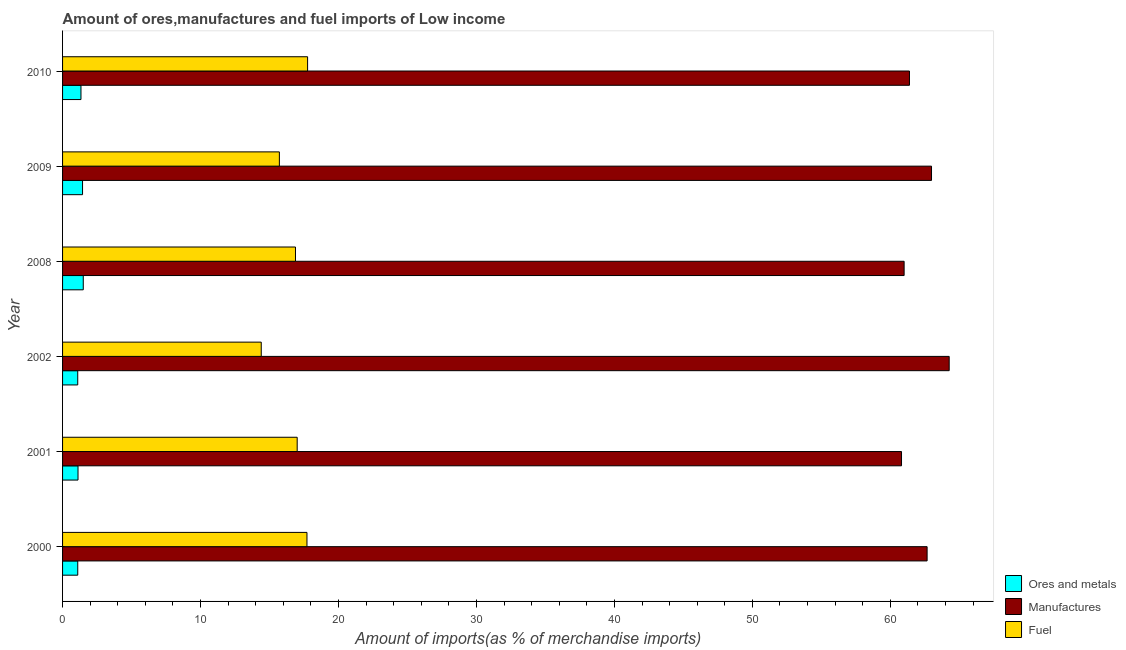How many different coloured bars are there?
Your answer should be compact. 3. How many bars are there on the 5th tick from the top?
Offer a very short reply. 3. How many bars are there on the 4th tick from the bottom?
Offer a very short reply. 3. What is the label of the 5th group of bars from the top?
Give a very brief answer. 2001. In how many cases, is the number of bars for a given year not equal to the number of legend labels?
Offer a very short reply. 0. What is the percentage of fuel imports in 2010?
Your response must be concise. 17.76. Across all years, what is the maximum percentage of manufactures imports?
Offer a very short reply. 64.27. Across all years, what is the minimum percentage of ores and metals imports?
Provide a short and direct response. 1.1. In which year was the percentage of ores and metals imports minimum?
Keep it short and to the point. 2002. What is the total percentage of manufactures imports in the graph?
Offer a terse response. 373.12. What is the difference between the percentage of fuel imports in 2000 and that in 2010?
Your answer should be compact. -0.04. What is the difference between the percentage of ores and metals imports in 2009 and the percentage of manufactures imports in 2000?
Offer a very short reply. -61.22. What is the average percentage of ores and metals imports per year?
Offer a terse response. 1.27. In the year 2002, what is the difference between the percentage of fuel imports and percentage of ores and metals imports?
Give a very brief answer. 13.3. Is the percentage of fuel imports in 2001 less than that in 2009?
Provide a short and direct response. No. Is the difference between the percentage of manufactures imports in 2000 and 2010 greater than the difference between the percentage of ores and metals imports in 2000 and 2010?
Offer a very short reply. Yes. What is the difference between the highest and the second highest percentage of manufactures imports?
Your answer should be very brief. 1.28. What is the difference between the highest and the lowest percentage of fuel imports?
Offer a terse response. 3.36. What does the 2nd bar from the top in 2001 represents?
Offer a very short reply. Manufactures. What does the 1st bar from the bottom in 2001 represents?
Your answer should be compact. Ores and metals. Is it the case that in every year, the sum of the percentage of ores and metals imports and percentage of manufactures imports is greater than the percentage of fuel imports?
Ensure brevity in your answer.  Yes. How many bars are there?
Offer a very short reply. 18. Are all the bars in the graph horizontal?
Make the answer very short. Yes. Are the values on the major ticks of X-axis written in scientific E-notation?
Provide a succinct answer. No. Does the graph contain grids?
Give a very brief answer. No. Where does the legend appear in the graph?
Ensure brevity in your answer.  Bottom right. What is the title of the graph?
Your response must be concise. Amount of ores,manufactures and fuel imports of Low income. What is the label or title of the X-axis?
Make the answer very short. Amount of imports(as % of merchandise imports). What is the label or title of the Y-axis?
Provide a short and direct response. Year. What is the Amount of imports(as % of merchandise imports) of Ores and metals in 2000?
Offer a terse response. 1.1. What is the Amount of imports(as % of merchandise imports) in Manufactures in 2000?
Ensure brevity in your answer.  62.67. What is the Amount of imports(as % of merchandise imports) in Fuel in 2000?
Your answer should be very brief. 17.72. What is the Amount of imports(as % of merchandise imports) in Ores and metals in 2001?
Provide a succinct answer. 1.12. What is the Amount of imports(as % of merchandise imports) in Manufactures in 2001?
Make the answer very short. 60.81. What is the Amount of imports(as % of merchandise imports) in Fuel in 2001?
Your answer should be very brief. 17.01. What is the Amount of imports(as % of merchandise imports) in Ores and metals in 2002?
Offer a very short reply. 1.1. What is the Amount of imports(as % of merchandise imports) in Manufactures in 2002?
Keep it short and to the point. 64.27. What is the Amount of imports(as % of merchandise imports) in Fuel in 2002?
Ensure brevity in your answer.  14.4. What is the Amount of imports(as % of merchandise imports) in Ores and metals in 2008?
Provide a succinct answer. 1.5. What is the Amount of imports(as % of merchandise imports) in Manufactures in 2008?
Give a very brief answer. 61. What is the Amount of imports(as % of merchandise imports) in Fuel in 2008?
Ensure brevity in your answer.  16.88. What is the Amount of imports(as % of merchandise imports) in Ores and metals in 2009?
Give a very brief answer. 1.45. What is the Amount of imports(as % of merchandise imports) of Manufactures in 2009?
Provide a short and direct response. 62.99. What is the Amount of imports(as % of merchandise imports) of Fuel in 2009?
Your response must be concise. 15.72. What is the Amount of imports(as % of merchandise imports) of Ores and metals in 2010?
Offer a terse response. 1.33. What is the Amount of imports(as % of merchandise imports) of Manufactures in 2010?
Make the answer very short. 61.39. What is the Amount of imports(as % of merchandise imports) of Fuel in 2010?
Offer a very short reply. 17.76. Across all years, what is the maximum Amount of imports(as % of merchandise imports) in Ores and metals?
Give a very brief answer. 1.5. Across all years, what is the maximum Amount of imports(as % of merchandise imports) of Manufactures?
Your answer should be very brief. 64.27. Across all years, what is the maximum Amount of imports(as % of merchandise imports) of Fuel?
Offer a terse response. 17.76. Across all years, what is the minimum Amount of imports(as % of merchandise imports) in Ores and metals?
Your response must be concise. 1.1. Across all years, what is the minimum Amount of imports(as % of merchandise imports) in Manufactures?
Your response must be concise. 60.81. Across all years, what is the minimum Amount of imports(as % of merchandise imports) of Fuel?
Give a very brief answer. 14.4. What is the total Amount of imports(as % of merchandise imports) of Ores and metals in the graph?
Offer a very short reply. 7.6. What is the total Amount of imports(as % of merchandise imports) in Manufactures in the graph?
Your answer should be very brief. 373.12. What is the total Amount of imports(as % of merchandise imports) of Fuel in the graph?
Your answer should be compact. 99.48. What is the difference between the Amount of imports(as % of merchandise imports) in Ores and metals in 2000 and that in 2001?
Your response must be concise. -0.02. What is the difference between the Amount of imports(as % of merchandise imports) in Manufactures in 2000 and that in 2001?
Provide a succinct answer. 1.86. What is the difference between the Amount of imports(as % of merchandise imports) in Fuel in 2000 and that in 2001?
Keep it short and to the point. 0.71. What is the difference between the Amount of imports(as % of merchandise imports) in Ores and metals in 2000 and that in 2002?
Offer a very short reply. 0. What is the difference between the Amount of imports(as % of merchandise imports) in Manufactures in 2000 and that in 2002?
Give a very brief answer. -1.6. What is the difference between the Amount of imports(as % of merchandise imports) of Fuel in 2000 and that in 2002?
Offer a very short reply. 3.31. What is the difference between the Amount of imports(as % of merchandise imports) in Ores and metals in 2000 and that in 2008?
Ensure brevity in your answer.  -0.4. What is the difference between the Amount of imports(as % of merchandise imports) of Manufactures in 2000 and that in 2008?
Give a very brief answer. 1.67. What is the difference between the Amount of imports(as % of merchandise imports) in Ores and metals in 2000 and that in 2009?
Provide a short and direct response. -0.35. What is the difference between the Amount of imports(as % of merchandise imports) of Manufactures in 2000 and that in 2009?
Offer a very short reply. -0.32. What is the difference between the Amount of imports(as % of merchandise imports) in Fuel in 2000 and that in 2009?
Your response must be concise. 2. What is the difference between the Amount of imports(as % of merchandise imports) in Ores and metals in 2000 and that in 2010?
Provide a short and direct response. -0.23. What is the difference between the Amount of imports(as % of merchandise imports) in Manufactures in 2000 and that in 2010?
Make the answer very short. 1.28. What is the difference between the Amount of imports(as % of merchandise imports) in Fuel in 2000 and that in 2010?
Keep it short and to the point. -0.04. What is the difference between the Amount of imports(as % of merchandise imports) of Ores and metals in 2001 and that in 2002?
Give a very brief answer. 0.02. What is the difference between the Amount of imports(as % of merchandise imports) of Manufactures in 2001 and that in 2002?
Ensure brevity in your answer.  -3.46. What is the difference between the Amount of imports(as % of merchandise imports) in Fuel in 2001 and that in 2002?
Offer a terse response. 2.6. What is the difference between the Amount of imports(as % of merchandise imports) of Ores and metals in 2001 and that in 2008?
Your answer should be compact. -0.38. What is the difference between the Amount of imports(as % of merchandise imports) in Manufactures in 2001 and that in 2008?
Ensure brevity in your answer.  -0.19. What is the difference between the Amount of imports(as % of merchandise imports) in Fuel in 2001 and that in 2008?
Give a very brief answer. 0.12. What is the difference between the Amount of imports(as % of merchandise imports) in Ores and metals in 2001 and that in 2009?
Your response must be concise. -0.33. What is the difference between the Amount of imports(as % of merchandise imports) of Manufactures in 2001 and that in 2009?
Make the answer very short. -2.17. What is the difference between the Amount of imports(as % of merchandise imports) of Fuel in 2001 and that in 2009?
Give a very brief answer. 1.29. What is the difference between the Amount of imports(as % of merchandise imports) of Ores and metals in 2001 and that in 2010?
Offer a terse response. -0.21. What is the difference between the Amount of imports(as % of merchandise imports) of Manufactures in 2001 and that in 2010?
Provide a short and direct response. -0.58. What is the difference between the Amount of imports(as % of merchandise imports) in Fuel in 2001 and that in 2010?
Keep it short and to the point. -0.75. What is the difference between the Amount of imports(as % of merchandise imports) in Ores and metals in 2002 and that in 2008?
Your answer should be very brief. -0.4. What is the difference between the Amount of imports(as % of merchandise imports) of Manufactures in 2002 and that in 2008?
Provide a short and direct response. 3.27. What is the difference between the Amount of imports(as % of merchandise imports) of Fuel in 2002 and that in 2008?
Your answer should be very brief. -2.48. What is the difference between the Amount of imports(as % of merchandise imports) of Ores and metals in 2002 and that in 2009?
Offer a very short reply. -0.35. What is the difference between the Amount of imports(as % of merchandise imports) in Manufactures in 2002 and that in 2009?
Your response must be concise. 1.28. What is the difference between the Amount of imports(as % of merchandise imports) of Fuel in 2002 and that in 2009?
Ensure brevity in your answer.  -1.31. What is the difference between the Amount of imports(as % of merchandise imports) of Ores and metals in 2002 and that in 2010?
Provide a short and direct response. -0.23. What is the difference between the Amount of imports(as % of merchandise imports) of Manufactures in 2002 and that in 2010?
Your response must be concise. 2.88. What is the difference between the Amount of imports(as % of merchandise imports) in Fuel in 2002 and that in 2010?
Your response must be concise. -3.36. What is the difference between the Amount of imports(as % of merchandise imports) of Ores and metals in 2008 and that in 2009?
Keep it short and to the point. 0.05. What is the difference between the Amount of imports(as % of merchandise imports) of Manufactures in 2008 and that in 2009?
Provide a succinct answer. -1.99. What is the difference between the Amount of imports(as % of merchandise imports) in Fuel in 2008 and that in 2009?
Your answer should be very brief. 1.17. What is the difference between the Amount of imports(as % of merchandise imports) in Ores and metals in 2008 and that in 2010?
Give a very brief answer. 0.17. What is the difference between the Amount of imports(as % of merchandise imports) of Manufactures in 2008 and that in 2010?
Your answer should be compact. -0.39. What is the difference between the Amount of imports(as % of merchandise imports) of Fuel in 2008 and that in 2010?
Keep it short and to the point. -0.88. What is the difference between the Amount of imports(as % of merchandise imports) of Ores and metals in 2009 and that in 2010?
Make the answer very short. 0.11. What is the difference between the Amount of imports(as % of merchandise imports) in Manufactures in 2009 and that in 2010?
Give a very brief answer. 1.6. What is the difference between the Amount of imports(as % of merchandise imports) in Fuel in 2009 and that in 2010?
Keep it short and to the point. -2.04. What is the difference between the Amount of imports(as % of merchandise imports) of Ores and metals in 2000 and the Amount of imports(as % of merchandise imports) of Manufactures in 2001?
Give a very brief answer. -59.71. What is the difference between the Amount of imports(as % of merchandise imports) of Ores and metals in 2000 and the Amount of imports(as % of merchandise imports) of Fuel in 2001?
Offer a terse response. -15.91. What is the difference between the Amount of imports(as % of merchandise imports) in Manufactures in 2000 and the Amount of imports(as % of merchandise imports) in Fuel in 2001?
Give a very brief answer. 45.66. What is the difference between the Amount of imports(as % of merchandise imports) of Ores and metals in 2000 and the Amount of imports(as % of merchandise imports) of Manufactures in 2002?
Make the answer very short. -63.17. What is the difference between the Amount of imports(as % of merchandise imports) of Ores and metals in 2000 and the Amount of imports(as % of merchandise imports) of Fuel in 2002?
Your answer should be very brief. -13.3. What is the difference between the Amount of imports(as % of merchandise imports) in Manufactures in 2000 and the Amount of imports(as % of merchandise imports) in Fuel in 2002?
Provide a short and direct response. 48.26. What is the difference between the Amount of imports(as % of merchandise imports) in Ores and metals in 2000 and the Amount of imports(as % of merchandise imports) in Manufactures in 2008?
Make the answer very short. -59.9. What is the difference between the Amount of imports(as % of merchandise imports) of Ores and metals in 2000 and the Amount of imports(as % of merchandise imports) of Fuel in 2008?
Ensure brevity in your answer.  -15.78. What is the difference between the Amount of imports(as % of merchandise imports) of Manufactures in 2000 and the Amount of imports(as % of merchandise imports) of Fuel in 2008?
Your response must be concise. 45.78. What is the difference between the Amount of imports(as % of merchandise imports) of Ores and metals in 2000 and the Amount of imports(as % of merchandise imports) of Manufactures in 2009?
Keep it short and to the point. -61.88. What is the difference between the Amount of imports(as % of merchandise imports) in Ores and metals in 2000 and the Amount of imports(as % of merchandise imports) in Fuel in 2009?
Give a very brief answer. -14.61. What is the difference between the Amount of imports(as % of merchandise imports) of Manufactures in 2000 and the Amount of imports(as % of merchandise imports) of Fuel in 2009?
Your response must be concise. 46.95. What is the difference between the Amount of imports(as % of merchandise imports) in Ores and metals in 2000 and the Amount of imports(as % of merchandise imports) in Manufactures in 2010?
Make the answer very short. -60.29. What is the difference between the Amount of imports(as % of merchandise imports) of Ores and metals in 2000 and the Amount of imports(as % of merchandise imports) of Fuel in 2010?
Ensure brevity in your answer.  -16.66. What is the difference between the Amount of imports(as % of merchandise imports) in Manufactures in 2000 and the Amount of imports(as % of merchandise imports) in Fuel in 2010?
Provide a short and direct response. 44.91. What is the difference between the Amount of imports(as % of merchandise imports) of Ores and metals in 2001 and the Amount of imports(as % of merchandise imports) of Manufactures in 2002?
Make the answer very short. -63.15. What is the difference between the Amount of imports(as % of merchandise imports) in Ores and metals in 2001 and the Amount of imports(as % of merchandise imports) in Fuel in 2002?
Keep it short and to the point. -13.28. What is the difference between the Amount of imports(as % of merchandise imports) of Manufactures in 2001 and the Amount of imports(as % of merchandise imports) of Fuel in 2002?
Your answer should be very brief. 46.41. What is the difference between the Amount of imports(as % of merchandise imports) in Ores and metals in 2001 and the Amount of imports(as % of merchandise imports) in Manufactures in 2008?
Make the answer very short. -59.88. What is the difference between the Amount of imports(as % of merchandise imports) in Ores and metals in 2001 and the Amount of imports(as % of merchandise imports) in Fuel in 2008?
Your answer should be very brief. -15.76. What is the difference between the Amount of imports(as % of merchandise imports) of Manufactures in 2001 and the Amount of imports(as % of merchandise imports) of Fuel in 2008?
Ensure brevity in your answer.  43.93. What is the difference between the Amount of imports(as % of merchandise imports) in Ores and metals in 2001 and the Amount of imports(as % of merchandise imports) in Manufactures in 2009?
Make the answer very short. -61.87. What is the difference between the Amount of imports(as % of merchandise imports) in Ores and metals in 2001 and the Amount of imports(as % of merchandise imports) in Fuel in 2009?
Your answer should be very brief. -14.6. What is the difference between the Amount of imports(as % of merchandise imports) of Manufactures in 2001 and the Amount of imports(as % of merchandise imports) of Fuel in 2009?
Ensure brevity in your answer.  45.1. What is the difference between the Amount of imports(as % of merchandise imports) in Ores and metals in 2001 and the Amount of imports(as % of merchandise imports) in Manufactures in 2010?
Offer a terse response. -60.27. What is the difference between the Amount of imports(as % of merchandise imports) of Ores and metals in 2001 and the Amount of imports(as % of merchandise imports) of Fuel in 2010?
Provide a succinct answer. -16.64. What is the difference between the Amount of imports(as % of merchandise imports) of Manufactures in 2001 and the Amount of imports(as % of merchandise imports) of Fuel in 2010?
Give a very brief answer. 43.05. What is the difference between the Amount of imports(as % of merchandise imports) of Ores and metals in 2002 and the Amount of imports(as % of merchandise imports) of Manufactures in 2008?
Offer a very short reply. -59.9. What is the difference between the Amount of imports(as % of merchandise imports) of Ores and metals in 2002 and the Amount of imports(as % of merchandise imports) of Fuel in 2008?
Your answer should be very brief. -15.78. What is the difference between the Amount of imports(as % of merchandise imports) of Manufactures in 2002 and the Amount of imports(as % of merchandise imports) of Fuel in 2008?
Give a very brief answer. 47.38. What is the difference between the Amount of imports(as % of merchandise imports) of Ores and metals in 2002 and the Amount of imports(as % of merchandise imports) of Manufactures in 2009?
Your answer should be compact. -61.89. What is the difference between the Amount of imports(as % of merchandise imports) in Ores and metals in 2002 and the Amount of imports(as % of merchandise imports) in Fuel in 2009?
Make the answer very short. -14.62. What is the difference between the Amount of imports(as % of merchandise imports) in Manufactures in 2002 and the Amount of imports(as % of merchandise imports) in Fuel in 2009?
Give a very brief answer. 48.55. What is the difference between the Amount of imports(as % of merchandise imports) in Ores and metals in 2002 and the Amount of imports(as % of merchandise imports) in Manufactures in 2010?
Offer a very short reply. -60.29. What is the difference between the Amount of imports(as % of merchandise imports) in Ores and metals in 2002 and the Amount of imports(as % of merchandise imports) in Fuel in 2010?
Your answer should be compact. -16.66. What is the difference between the Amount of imports(as % of merchandise imports) in Manufactures in 2002 and the Amount of imports(as % of merchandise imports) in Fuel in 2010?
Your answer should be very brief. 46.51. What is the difference between the Amount of imports(as % of merchandise imports) in Ores and metals in 2008 and the Amount of imports(as % of merchandise imports) in Manufactures in 2009?
Give a very brief answer. -61.49. What is the difference between the Amount of imports(as % of merchandise imports) of Ores and metals in 2008 and the Amount of imports(as % of merchandise imports) of Fuel in 2009?
Provide a short and direct response. -14.22. What is the difference between the Amount of imports(as % of merchandise imports) in Manufactures in 2008 and the Amount of imports(as % of merchandise imports) in Fuel in 2009?
Give a very brief answer. 45.28. What is the difference between the Amount of imports(as % of merchandise imports) of Ores and metals in 2008 and the Amount of imports(as % of merchandise imports) of Manufactures in 2010?
Keep it short and to the point. -59.89. What is the difference between the Amount of imports(as % of merchandise imports) of Ores and metals in 2008 and the Amount of imports(as % of merchandise imports) of Fuel in 2010?
Your answer should be compact. -16.26. What is the difference between the Amount of imports(as % of merchandise imports) in Manufactures in 2008 and the Amount of imports(as % of merchandise imports) in Fuel in 2010?
Offer a very short reply. 43.24. What is the difference between the Amount of imports(as % of merchandise imports) of Ores and metals in 2009 and the Amount of imports(as % of merchandise imports) of Manufactures in 2010?
Ensure brevity in your answer.  -59.94. What is the difference between the Amount of imports(as % of merchandise imports) in Ores and metals in 2009 and the Amount of imports(as % of merchandise imports) in Fuel in 2010?
Ensure brevity in your answer.  -16.31. What is the difference between the Amount of imports(as % of merchandise imports) of Manufactures in 2009 and the Amount of imports(as % of merchandise imports) of Fuel in 2010?
Provide a short and direct response. 45.22. What is the average Amount of imports(as % of merchandise imports) of Ores and metals per year?
Your answer should be compact. 1.27. What is the average Amount of imports(as % of merchandise imports) of Manufactures per year?
Keep it short and to the point. 62.19. What is the average Amount of imports(as % of merchandise imports) of Fuel per year?
Offer a very short reply. 16.58. In the year 2000, what is the difference between the Amount of imports(as % of merchandise imports) of Ores and metals and Amount of imports(as % of merchandise imports) of Manufactures?
Keep it short and to the point. -61.57. In the year 2000, what is the difference between the Amount of imports(as % of merchandise imports) of Ores and metals and Amount of imports(as % of merchandise imports) of Fuel?
Ensure brevity in your answer.  -16.62. In the year 2000, what is the difference between the Amount of imports(as % of merchandise imports) of Manufactures and Amount of imports(as % of merchandise imports) of Fuel?
Your answer should be compact. 44.95. In the year 2001, what is the difference between the Amount of imports(as % of merchandise imports) in Ores and metals and Amount of imports(as % of merchandise imports) in Manufactures?
Keep it short and to the point. -59.69. In the year 2001, what is the difference between the Amount of imports(as % of merchandise imports) in Ores and metals and Amount of imports(as % of merchandise imports) in Fuel?
Provide a short and direct response. -15.89. In the year 2001, what is the difference between the Amount of imports(as % of merchandise imports) in Manufactures and Amount of imports(as % of merchandise imports) in Fuel?
Ensure brevity in your answer.  43.8. In the year 2002, what is the difference between the Amount of imports(as % of merchandise imports) of Ores and metals and Amount of imports(as % of merchandise imports) of Manufactures?
Give a very brief answer. -63.17. In the year 2002, what is the difference between the Amount of imports(as % of merchandise imports) of Ores and metals and Amount of imports(as % of merchandise imports) of Fuel?
Your answer should be compact. -13.3. In the year 2002, what is the difference between the Amount of imports(as % of merchandise imports) of Manufactures and Amount of imports(as % of merchandise imports) of Fuel?
Your answer should be very brief. 49.87. In the year 2008, what is the difference between the Amount of imports(as % of merchandise imports) of Ores and metals and Amount of imports(as % of merchandise imports) of Manufactures?
Provide a short and direct response. -59.5. In the year 2008, what is the difference between the Amount of imports(as % of merchandise imports) in Ores and metals and Amount of imports(as % of merchandise imports) in Fuel?
Your answer should be compact. -15.38. In the year 2008, what is the difference between the Amount of imports(as % of merchandise imports) of Manufactures and Amount of imports(as % of merchandise imports) of Fuel?
Keep it short and to the point. 44.12. In the year 2009, what is the difference between the Amount of imports(as % of merchandise imports) of Ores and metals and Amount of imports(as % of merchandise imports) of Manufactures?
Your answer should be very brief. -61.54. In the year 2009, what is the difference between the Amount of imports(as % of merchandise imports) of Ores and metals and Amount of imports(as % of merchandise imports) of Fuel?
Your answer should be very brief. -14.27. In the year 2009, what is the difference between the Amount of imports(as % of merchandise imports) of Manufactures and Amount of imports(as % of merchandise imports) of Fuel?
Make the answer very short. 47.27. In the year 2010, what is the difference between the Amount of imports(as % of merchandise imports) in Ores and metals and Amount of imports(as % of merchandise imports) in Manufactures?
Your answer should be compact. -60.05. In the year 2010, what is the difference between the Amount of imports(as % of merchandise imports) in Ores and metals and Amount of imports(as % of merchandise imports) in Fuel?
Provide a succinct answer. -16.43. In the year 2010, what is the difference between the Amount of imports(as % of merchandise imports) of Manufactures and Amount of imports(as % of merchandise imports) of Fuel?
Your response must be concise. 43.63. What is the ratio of the Amount of imports(as % of merchandise imports) of Ores and metals in 2000 to that in 2001?
Your answer should be compact. 0.98. What is the ratio of the Amount of imports(as % of merchandise imports) of Manufactures in 2000 to that in 2001?
Provide a succinct answer. 1.03. What is the ratio of the Amount of imports(as % of merchandise imports) in Fuel in 2000 to that in 2001?
Your answer should be compact. 1.04. What is the ratio of the Amount of imports(as % of merchandise imports) in Manufactures in 2000 to that in 2002?
Give a very brief answer. 0.98. What is the ratio of the Amount of imports(as % of merchandise imports) of Fuel in 2000 to that in 2002?
Offer a very short reply. 1.23. What is the ratio of the Amount of imports(as % of merchandise imports) in Ores and metals in 2000 to that in 2008?
Offer a very short reply. 0.73. What is the ratio of the Amount of imports(as % of merchandise imports) of Manufactures in 2000 to that in 2008?
Your answer should be very brief. 1.03. What is the ratio of the Amount of imports(as % of merchandise imports) of Fuel in 2000 to that in 2008?
Your response must be concise. 1.05. What is the ratio of the Amount of imports(as % of merchandise imports) in Ores and metals in 2000 to that in 2009?
Your answer should be very brief. 0.76. What is the ratio of the Amount of imports(as % of merchandise imports) of Manufactures in 2000 to that in 2009?
Provide a short and direct response. 0.99. What is the ratio of the Amount of imports(as % of merchandise imports) of Fuel in 2000 to that in 2009?
Your answer should be very brief. 1.13. What is the ratio of the Amount of imports(as % of merchandise imports) of Ores and metals in 2000 to that in 2010?
Your answer should be very brief. 0.83. What is the ratio of the Amount of imports(as % of merchandise imports) of Manufactures in 2000 to that in 2010?
Provide a short and direct response. 1.02. What is the ratio of the Amount of imports(as % of merchandise imports) of Fuel in 2000 to that in 2010?
Offer a very short reply. 1. What is the ratio of the Amount of imports(as % of merchandise imports) of Ores and metals in 2001 to that in 2002?
Give a very brief answer. 1.02. What is the ratio of the Amount of imports(as % of merchandise imports) of Manufactures in 2001 to that in 2002?
Make the answer very short. 0.95. What is the ratio of the Amount of imports(as % of merchandise imports) of Fuel in 2001 to that in 2002?
Your answer should be compact. 1.18. What is the ratio of the Amount of imports(as % of merchandise imports) in Ores and metals in 2001 to that in 2008?
Make the answer very short. 0.75. What is the ratio of the Amount of imports(as % of merchandise imports) of Manufactures in 2001 to that in 2008?
Ensure brevity in your answer.  1. What is the ratio of the Amount of imports(as % of merchandise imports) in Fuel in 2001 to that in 2008?
Provide a short and direct response. 1.01. What is the ratio of the Amount of imports(as % of merchandise imports) of Ores and metals in 2001 to that in 2009?
Give a very brief answer. 0.77. What is the ratio of the Amount of imports(as % of merchandise imports) of Manufactures in 2001 to that in 2009?
Your response must be concise. 0.97. What is the ratio of the Amount of imports(as % of merchandise imports) in Fuel in 2001 to that in 2009?
Your answer should be compact. 1.08. What is the ratio of the Amount of imports(as % of merchandise imports) of Ores and metals in 2001 to that in 2010?
Your answer should be compact. 0.84. What is the ratio of the Amount of imports(as % of merchandise imports) of Manufactures in 2001 to that in 2010?
Ensure brevity in your answer.  0.99. What is the ratio of the Amount of imports(as % of merchandise imports) in Fuel in 2001 to that in 2010?
Give a very brief answer. 0.96. What is the ratio of the Amount of imports(as % of merchandise imports) in Ores and metals in 2002 to that in 2008?
Your response must be concise. 0.73. What is the ratio of the Amount of imports(as % of merchandise imports) of Manufactures in 2002 to that in 2008?
Offer a very short reply. 1.05. What is the ratio of the Amount of imports(as % of merchandise imports) in Fuel in 2002 to that in 2008?
Your response must be concise. 0.85. What is the ratio of the Amount of imports(as % of merchandise imports) of Ores and metals in 2002 to that in 2009?
Give a very brief answer. 0.76. What is the ratio of the Amount of imports(as % of merchandise imports) of Manufactures in 2002 to that in 2009?
Your answer should be very brief. 1.02. What is the ratio of the Amount of imports(as % of merchandise imports) of Fuel in 2002 to that in 2009?
Provide a succinct answer. 0.92. What is the ratio of the Amount of imports(as % of merchandise imports) of Ores and metals in 2002 to that in 2010?
Ensure brevity in your answer.  0.82. What is the ratio of the Amount of imports(as % of merchandise imports) of Manufactures in 2002 to that in 2010?
Your response must be concise. 1.05. What is the ratio of the Amount of imports(as % of merchandise imports) in Fuel in 2002 to that in 2010?
Offer a very short reply. 0.81. What is the ratio of the Amount of imports(as % of merchandise imports) in Ores and metals in 2008 to that in 2009?
Offer a terse response. 1.04. What is the ratio of the Amount of imports(as % of merchandise imports) of Manufactures in 2008 to that in 2009?
Make the answer very short. 0.97. What is the ratio of the Amount of imports(as % of merchandise imports) in Fuel in 2008 to that in 2009?
Offer a terse response. 1.07. What is the ratio of the Amount of imports(as % of merchandise imports) of Ores and metals in 2008 to that in 2010?
Provide a short and direct response. 1.12. What is the ratio of the Amount of imports(as % of merchandise imports) of Manufactures in 2008 to that in 2010?
Your answer should be very brief. 0.99. What is the ratio of the Amount of imports(as % of merchandise imports) of Fuel in 2008 to that in 2010?
Provide a succinct answer. 0.95. What is the ratio of the Amount of imports(as % of merchandise imports) in Ores and metals in 2009 to that in 2010?
Provide a short and direct response. 1.09. What is the ratio of the Amount of imports(as % of merchandise imports) of Fuel in 2009 to that in 2010?
Offer a terse response. 0.88. What is the difference between the highest and the second highest Amount of imports(as % of merchandise imports) of Ores and metals?
Your answer should be very brief. 0.05. What is the difference between the highest and the second highest Amount of imports(as % of merchandise imports) in Manufactures?
Keep it short and to the point. 1.28. What is the difference between the highest and the second highest Amount of imports(as % of merchandise imports) in Fuel?
Your answer should be compact. 0.04. What is the difference between the highest and the lowest Amount of imports(as % of merchandise imports) in Ores and metals?
Offer a terse response. 0.4. What is the difference between the highest and the lowest Amount of imports(as % of merchandise imports) in Manufactures?
Offer a very short reply. 3.46. What is the difference between the highest and the lowest Amount of imports(as % of merchandise imports) of Fuel?
Your answer should be compact. 3.36. 